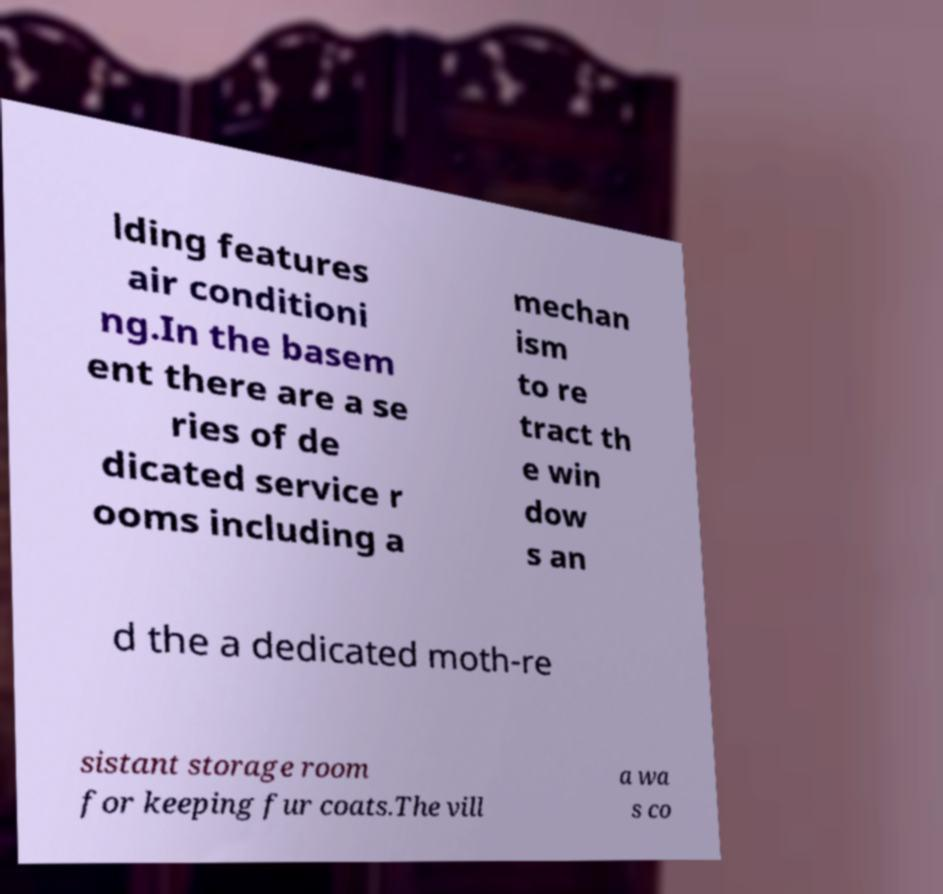What messages or text are displayed in this image? I need them in a readable, typed format. lding features air conditioni ng.In the basem ent there are a se ries of de dicated service r ooms including a mechan ism to re tract th e win dow s an d the a dedicated moth-re sistant storage room for keeping fur coats.The vill a wa s co 